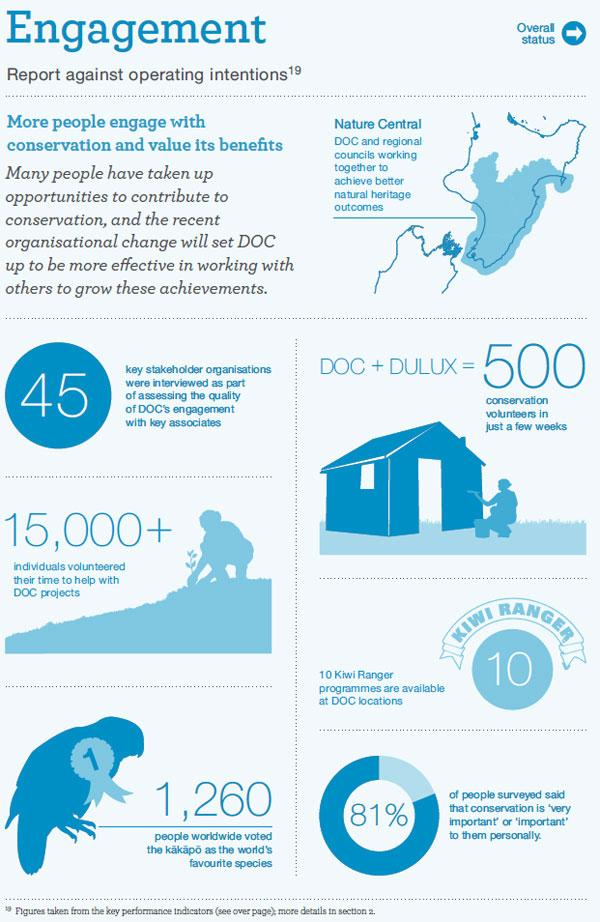Specify some key components in this picture. The number on the bird is 1.. This infographic contains two people's icons. According to a recent survey, only 19% of people believe that conservation is important. 